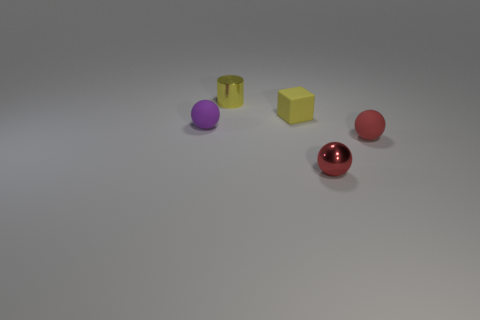Does the small metal sphere have the same color as the matte object that is in front of the purple rubber object?
Your answer should be very brief. Yes. There is a thing on the left side of the yellow metal cylinder; does it have the same color as the matte object that is in front of the purple object?
Offer a very short reply. No. What is the small sphere that is behind the red ball that is right of the sphere in front of the red matte ball made of?
Keep it short and to the point. Rubber. Is the purple matte object the same shape as the small red rubber object?
Offer a very short reply. Yes. What material is the other tiny red object that is the same shape as the red matte object?
Keep it short and to the point. Metal. How many metallic spheres have the same color as the cylinder?
Make the answer very short. 0. How many yellow objects are either small rubber cubes or tiny rubber objects?
Ensure brevity in your answer.  1. There is a matte ball on the left side of the yellow cylinder; how many tiny purple spheres are to the left of it?
Your response must be concise. 0. Are there more red rubber objects behind the metallic sphere than tiny red objects behind the cube?
Offer a very short reply. Yes. What material is the cylinder?
Make the answer very short. Metal. 